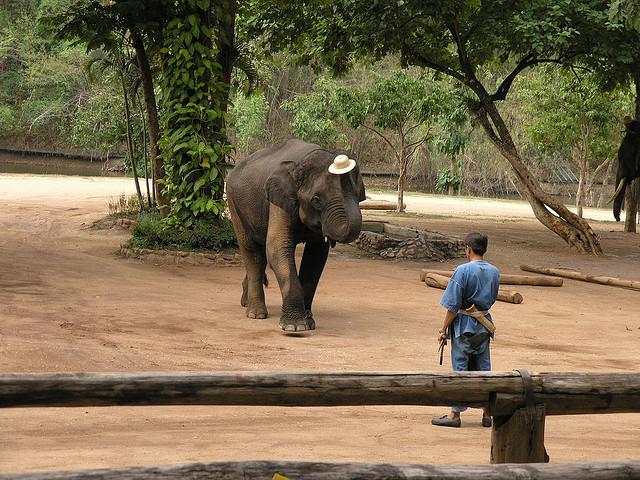Where is the elephant?
Short answer required. In front of man. What color are the clothes the man is wearing?
Keep it brief. Blue. Is the elephant playing basketball?
Answer briefly. No. Is there any trees around?
Write a very short answer. Yes. What is on the elephant?
Answer briefly. Hat. Is this an Indian elephant?
Concise answer only. Yes. Is this photo entertaining?
Short answer required. Yes. 